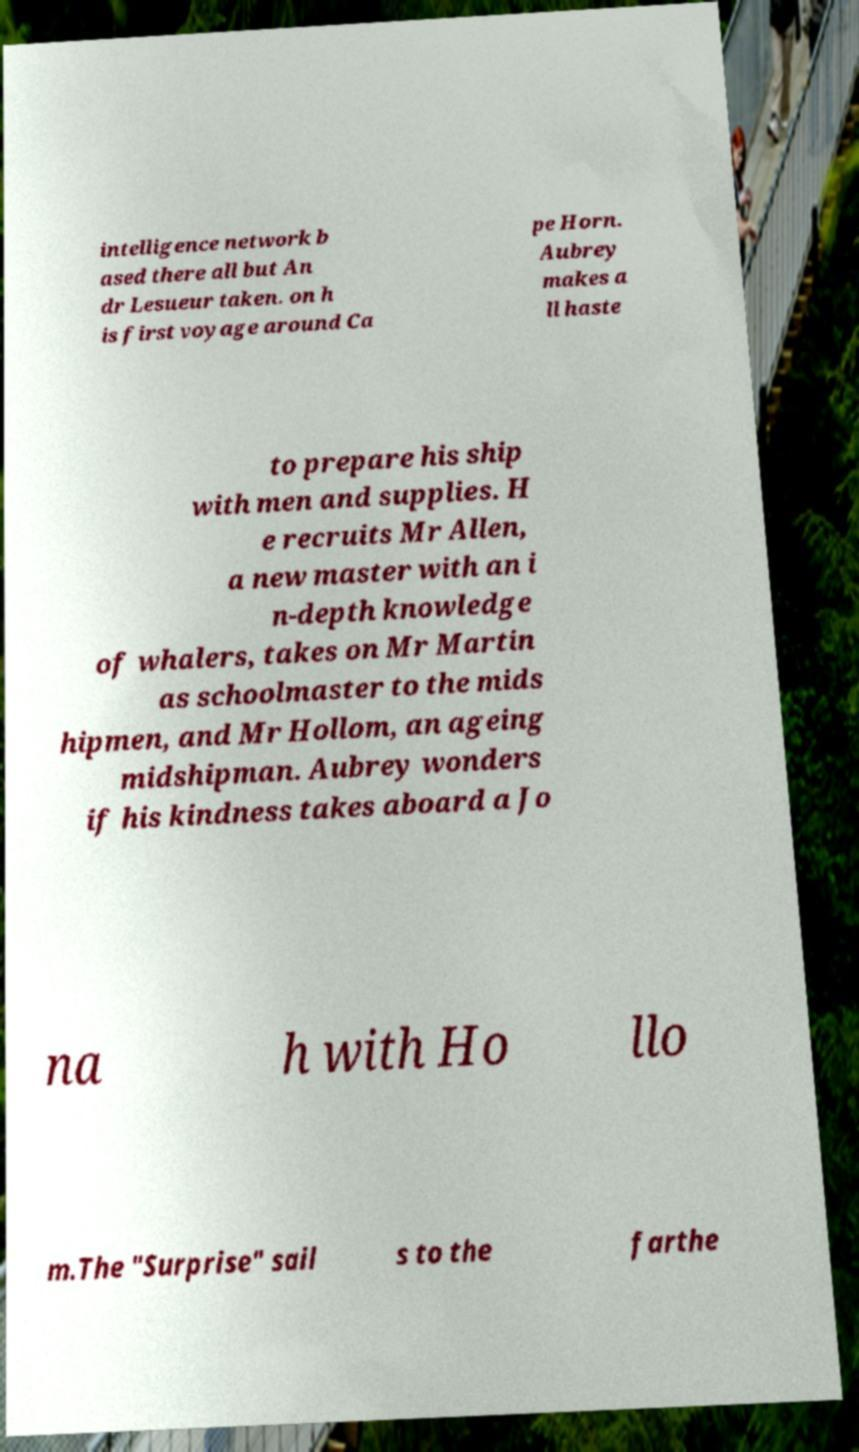Could you assist in decoding the text presented in this image and type it out clearly? intelligence network b ased there all but An dr Lesueur taken. on h is first voyage around Ca pe Horn. Aubrey makes a ll haste to prepare his ship with men and supplies. H e recruits Mr Allen, a new master with an i n-depth knowledge of whalers, takes on Mr Martin as schoolmaster to the mids hipmen, and Mr Hollom, an ageing midshipman. Aubrey wonders if his kindness takes aboard a Jo na h with Ho llo m.The "Surprise" sail s to the farthe 